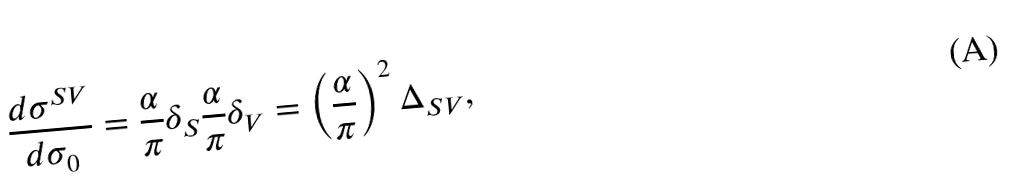<formula> <loc_0><loc_0><loc_500><loc_500>\frac { d \sigma ^ { S V } } { d \sigma _ { 0 } } = \frac { \alpha } { \pi } \delta _ { S } \frac { \alpha } { \pi } \delta _ { V } = \left ( \frac { \alpha } { \pi } \right ) ^ { 2 } \Delta _ { S V } ,</formula> 